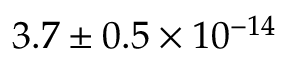<formula> <loc_0><loc_0><loc_500><loc_500>3 . 7 \pm { 0 . 5 } \times 1 0 ^ { - 1 4 }</formula> 